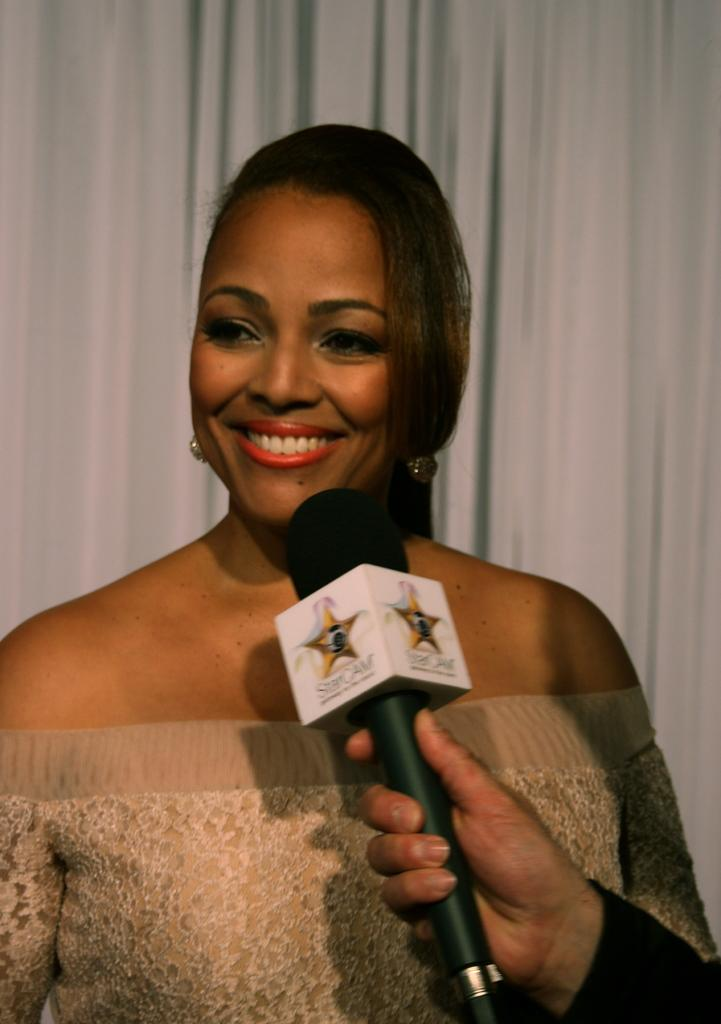Who is the main subject in the image? There is a woman in the center of the image. What is the woman doing in the image? The woman is smiling. Can you describe any other person in the image? Yes, there is a person holding a microphone in the image. What can be seen in the background of the image? There is a curtain in the background of the image. How does the woman push the yard in the image? There is no yard present in the image, and the woman is not pushing anything. 